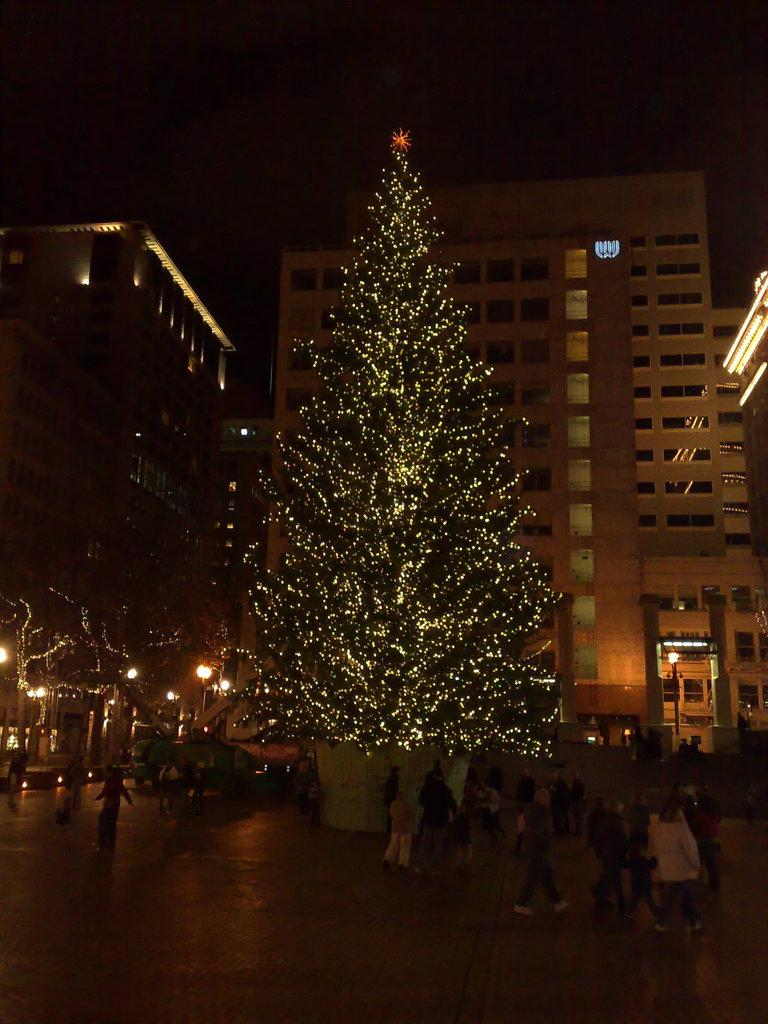What type of structures can be seen in the image? There are many buildings in the image. What other elements are present in the image besides buildings? There are trees and people standing in the image. Can you describe the mode of transportation visible in the image? There is a vehicle in the image. What type of plastic material can be seen covering the trees in the image? There is no plastic material covering the trees in the image; the trees are not covered at all. 